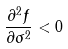<formula> <loc_0><loc_0><loc_500><loc_500>\frac { \partial ^ { 2 } f } { \partial \sigma ^ { 2 } } < 0</formula> 